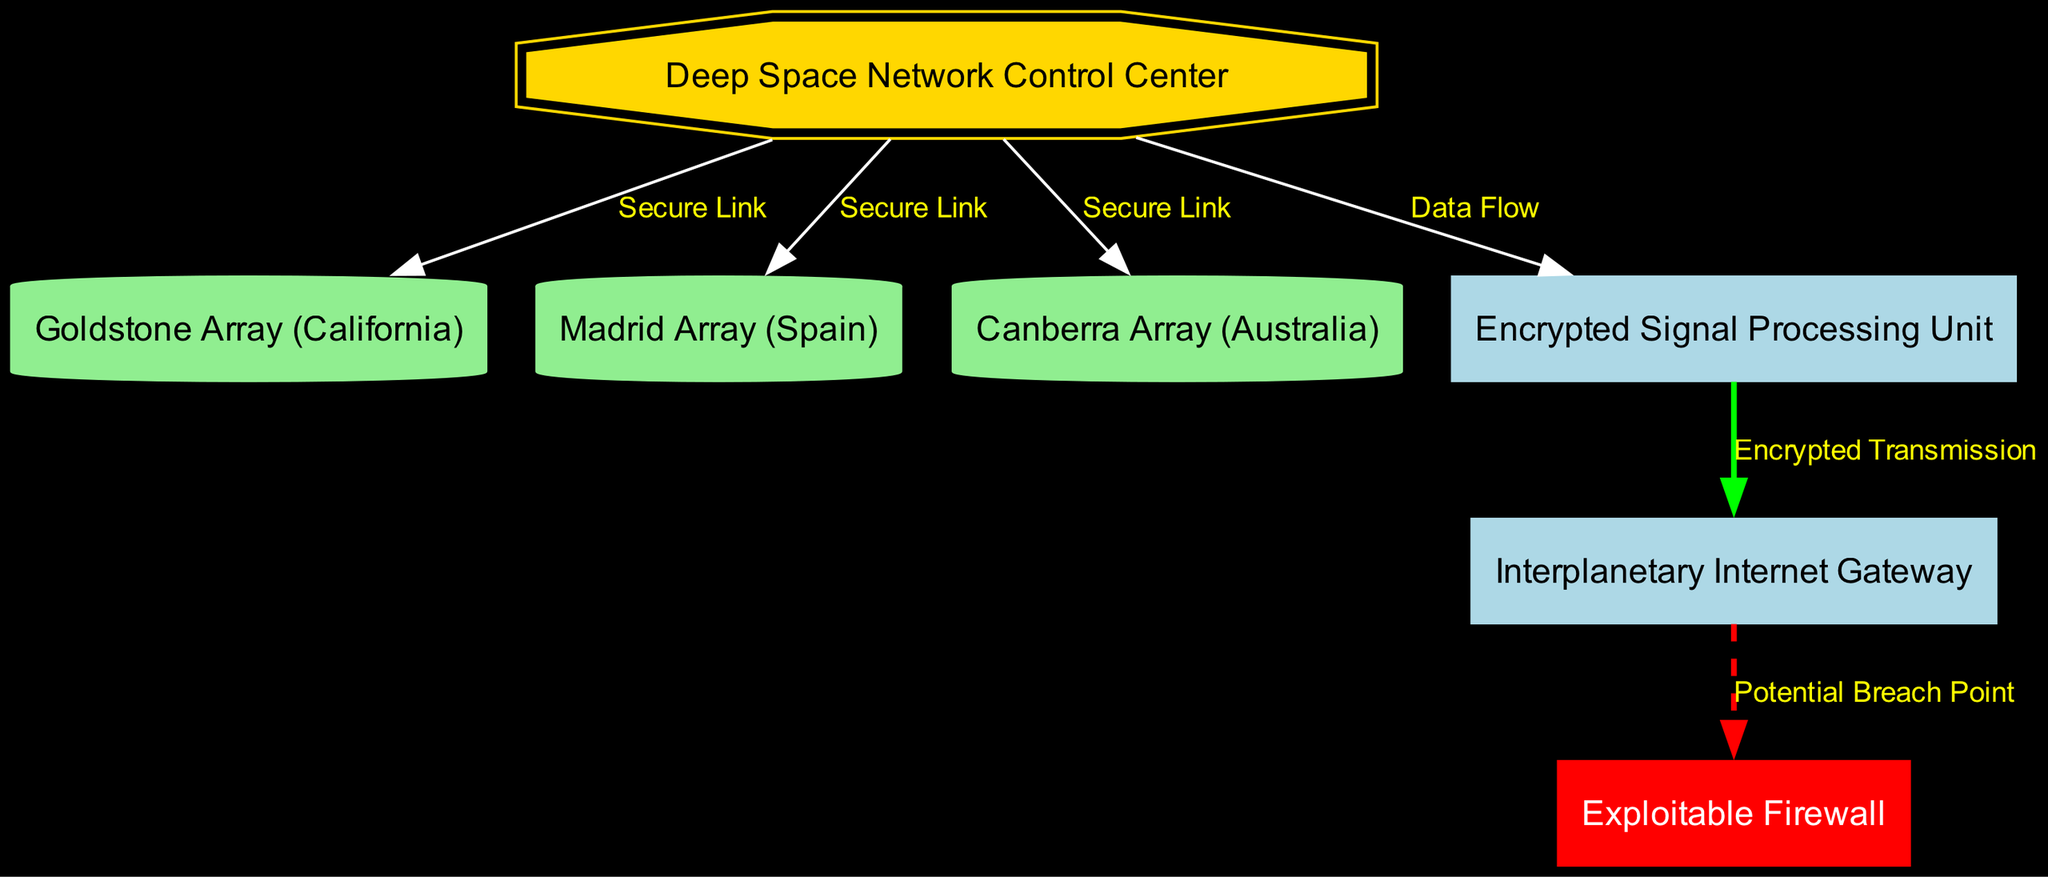What is the label of the node labeled '1'? The node labeled '1' is identified as the "Deep Space Network Control Center," which is explicitly provided in the diagram data for that node.
Answer: Deep Space Network Control Center How many nodes are present in the diagram? By counting the entries in the provided nodes list, there are a total of seven nodes present in the diagram.
Answer: 7 What connection type exists between the Control Center and the Goldstone Array? The edge connecting the Control Center (node '1') to the Goldstone Array (node '2') is labeled "Secure Link," indicating this specific type of connection.
Answer: Secure Link Which node highlights the potential breach point? In the diagram, the node labeled '7', called "Exploitable Firewall," is highlighted in red to signify it as the potential breach point.
Answer: Exploitable Firewall What's the relationship between the Encrypted Signal Processing Unit and the Interplanetary Internet Gateway? The edge connecting the Encrypted Signal Processing Unit (node '5') to the Interplanetary Internet Gateway (node '6') is labeled "Encrypted Transmission," illustrating the nature of their relationship as an encrypted link.
Answer: Encrypted Transmission How many secure links are present in the diagram? The diagram data shows that there are three secure links connecting the Deep Space Network Control Center to the three array nodes (Goldstone, Madrid, and Canberra).
Answer: 3 What color is the node representing the Encrypted Signal Processing Unit? The node representing the Encrypted Signal Processing Unit (node '5') is displayed in the default color as described in the graph attributes, in this case, it would be light blue by design as it is not specified to be special colored.
Answer: Light blue Which node is directly connected to the Interplanetary Internet Gateway? The Interplanetary Internet Gateway (node '6') is directly connected from the Encrypted Signal Processing Unit (node '5') as shown in the edges data.
Answer: Encrypted Signal Processing Unit What is indicated by the dashed line connecting the Interplanetary Internet Gateway to the Exploitable Firewall? The dashed line between the Interplanetary Internet Gateway (node '6') and the Exploitable Firewall (node '7') is labeled "Potential Breach Point," indicating a risk associated with that connection.
Answer: Potential Breach Point 